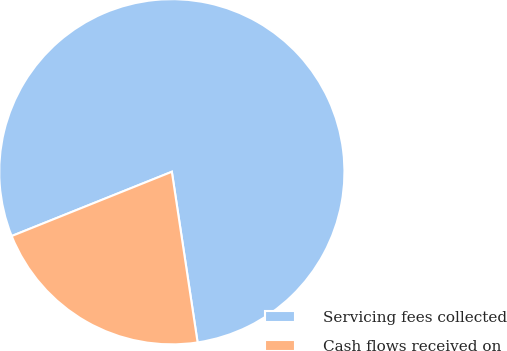<chart> <loc_0><loc_0><loc_500><loc_500><pie_chart><fcel>Servicing fees collected<fcel>Cash flows received on<nl><fcel>78.69%<fcel>21.31%<nl></chart> 